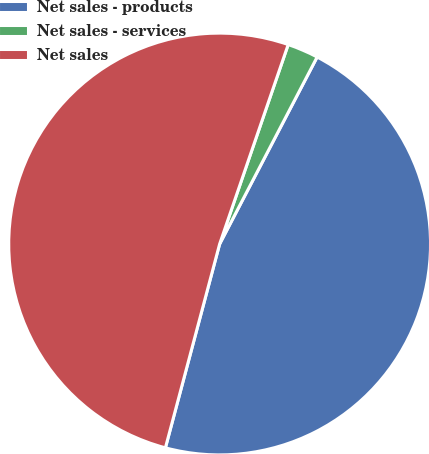Convert chart to OTSL. <chart><loc_0><loc_0><loc_500><loc_500><pie_chart><fcel>Net sales - products<fcel>Net sales - services<fcel>Net sales<nl><fcel>46.49%<fcel>2.38%<fcel>51.13%<nl></chart> 